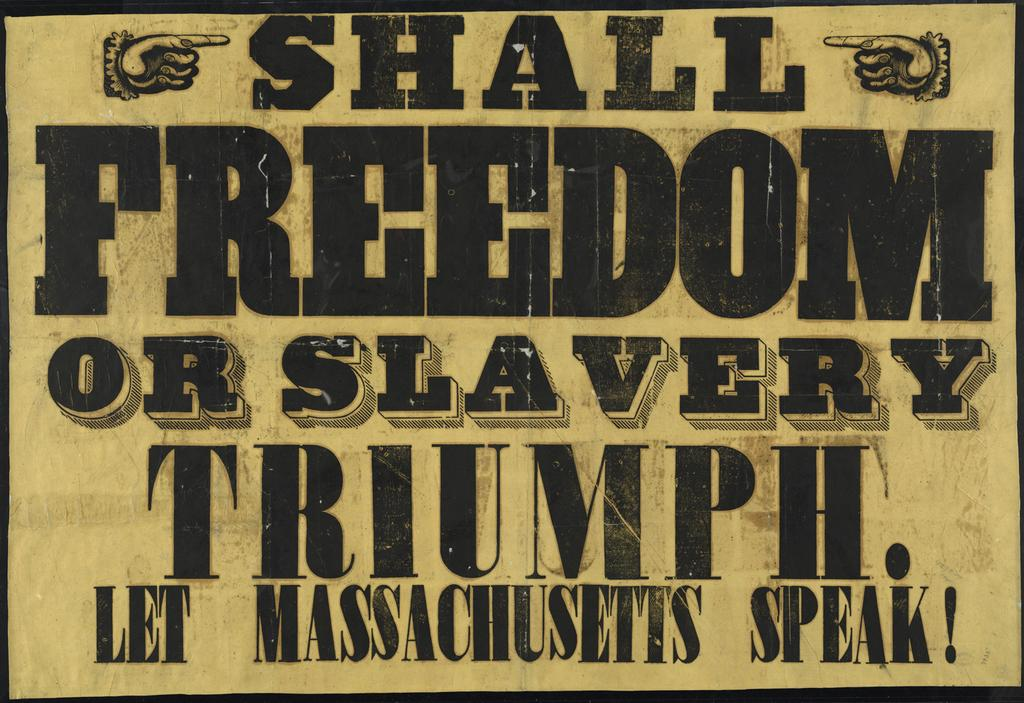<image>
Present a compact description of the photo's key features. A banner advocating for freedom of slavery in Massachusetts. 